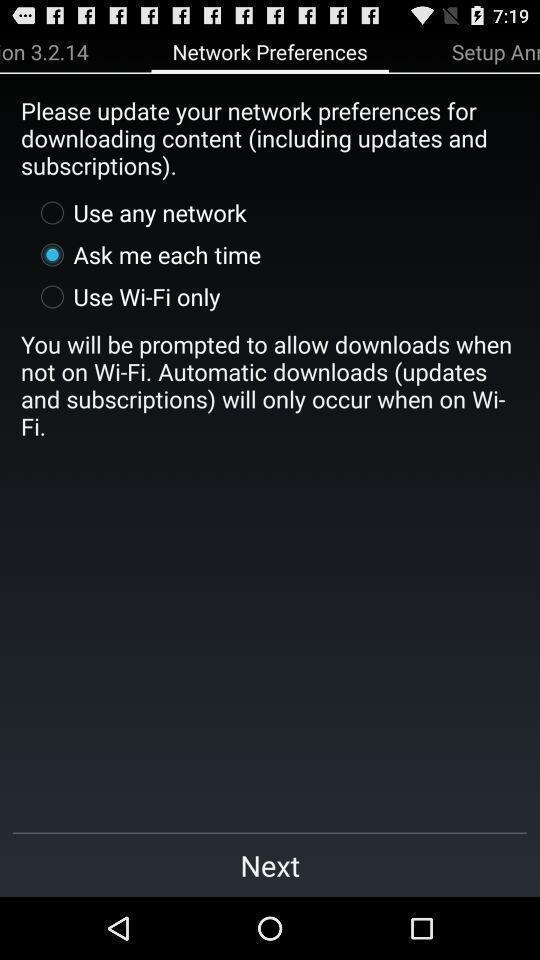Tell me about the visual elements in this screen capture. Window displaying a study app. 